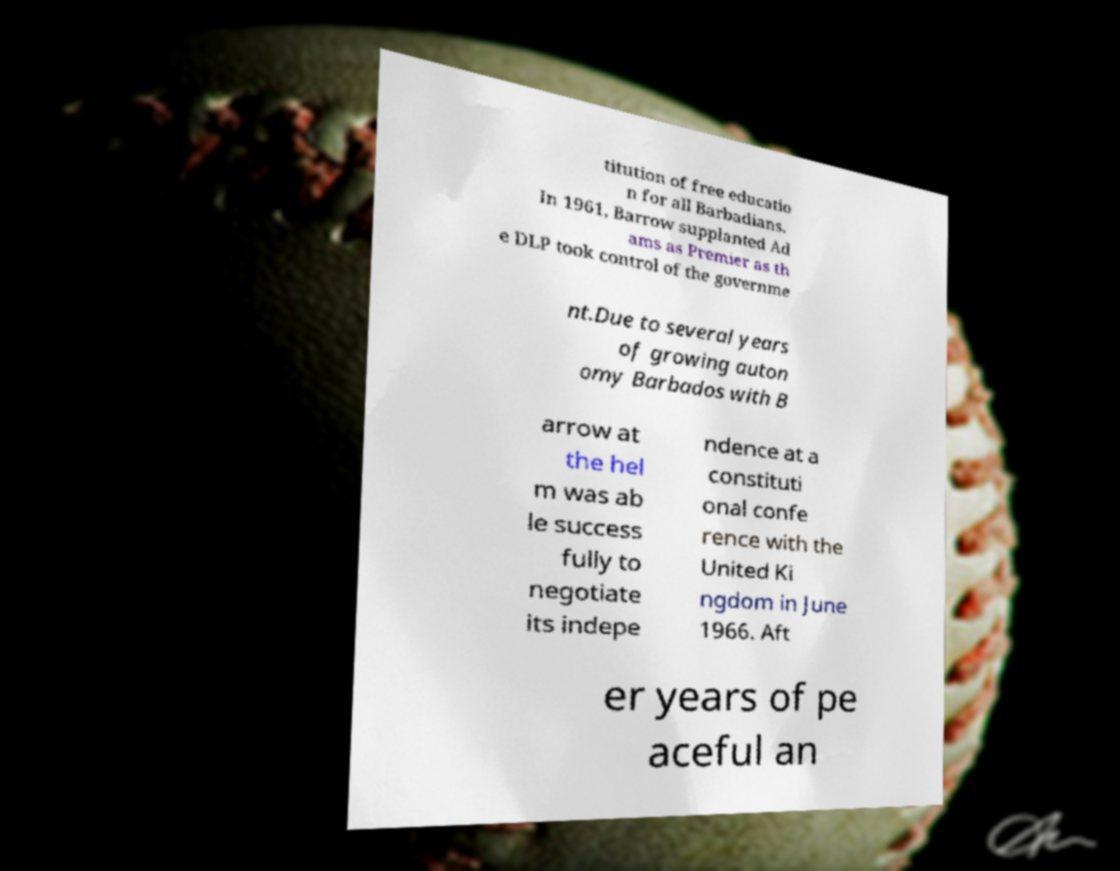For documentation purposes, I need the text within this image transcribed. Could you provide that? titution of free educatio n for all Barbadians. In 1961, Barrow supplanted Ad ams as Premier as th e DLP took control of the governme nt.Due to several years of growing auton omy Barbados with B arrow at the hel m was ab le success fully to negotiate its indepe ndence at a constituti onal confe rence with the United Ki ngdom in June 1966. Aft er years of pe aceful an 